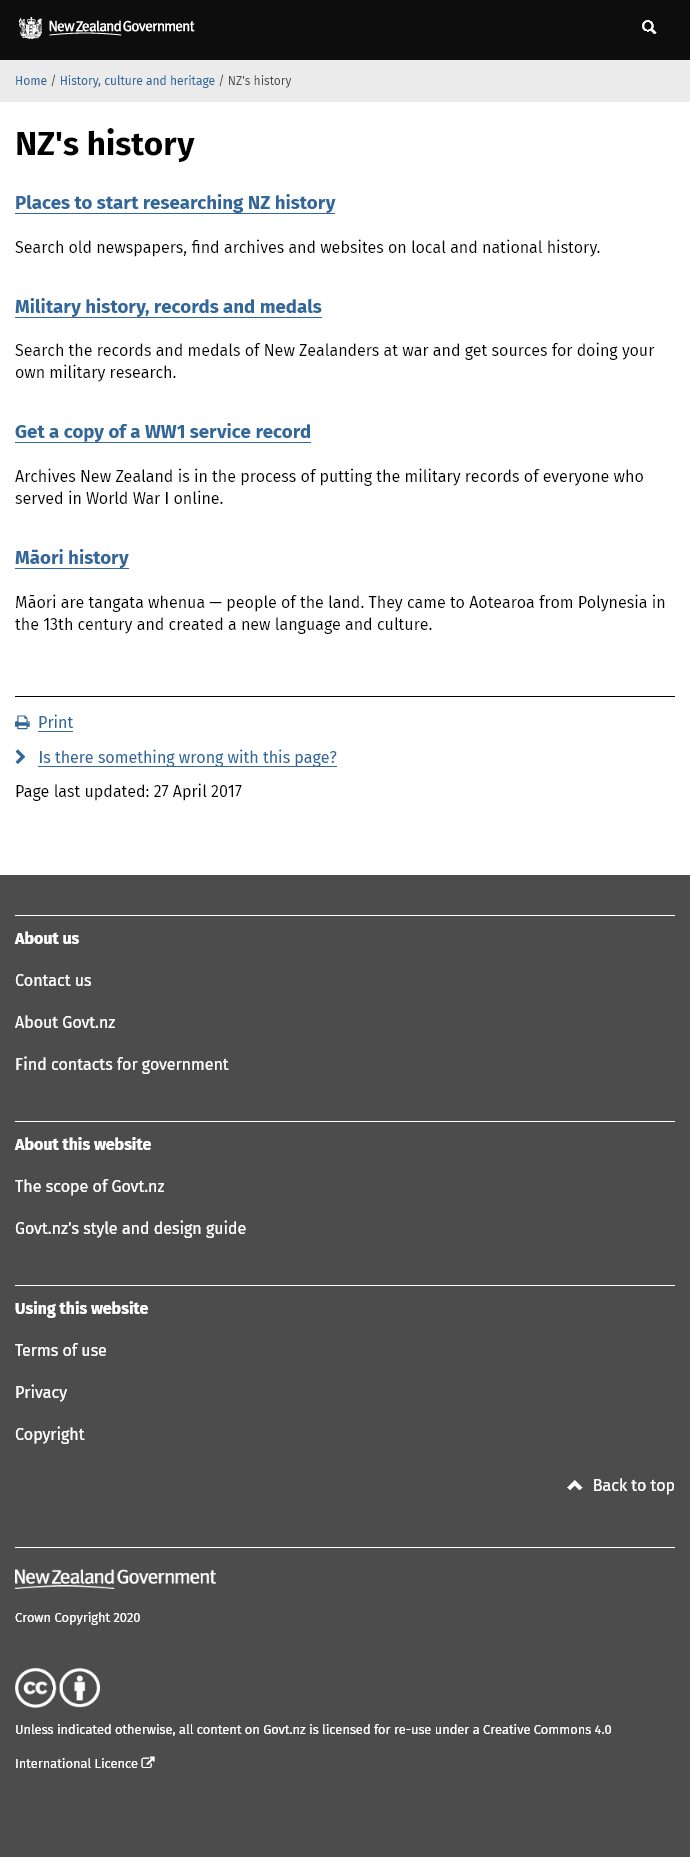Point out several critical features in this image. Searching old newspapers is an excellent example of a method for researching New Zealand history as it provides a valuable resource for discovering information about events, individuals, and social trends that occurred in the past. Archives New Zealand is currently engaged in the process of making the military records of all individuals who served in World War I accessible and available online to the public. The Maori are the people of the land. 